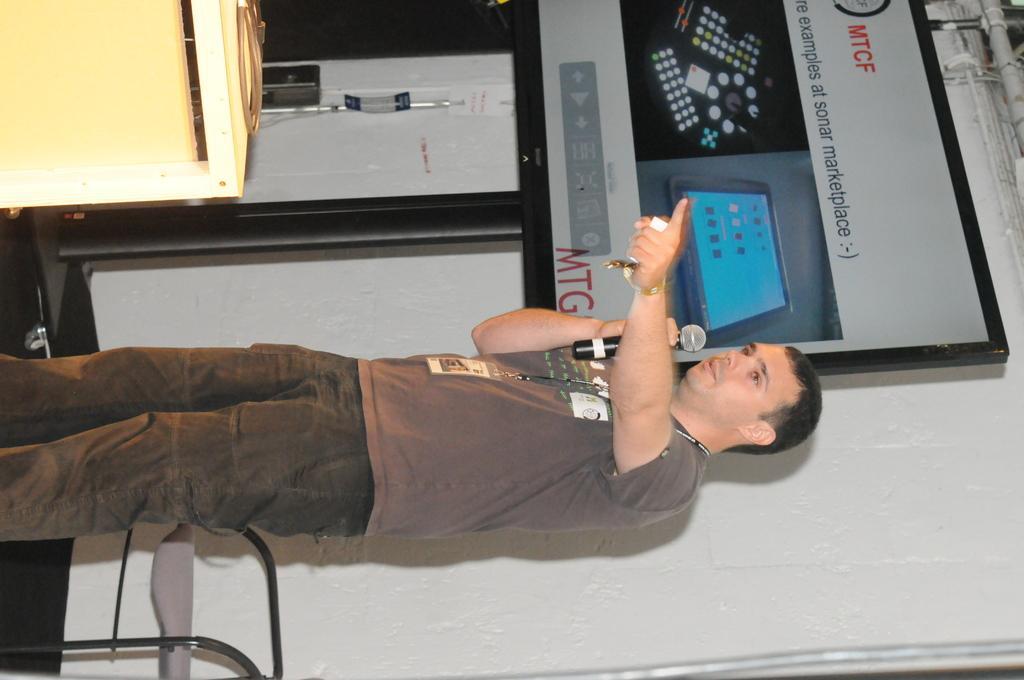Describe this image in one or two sentences. In this picture there is a man wearing a brown color T shirt. He is standing, holding a mic in his hand. We can observe a board here. There is a table which is in cream color. In the background there is a wall. 